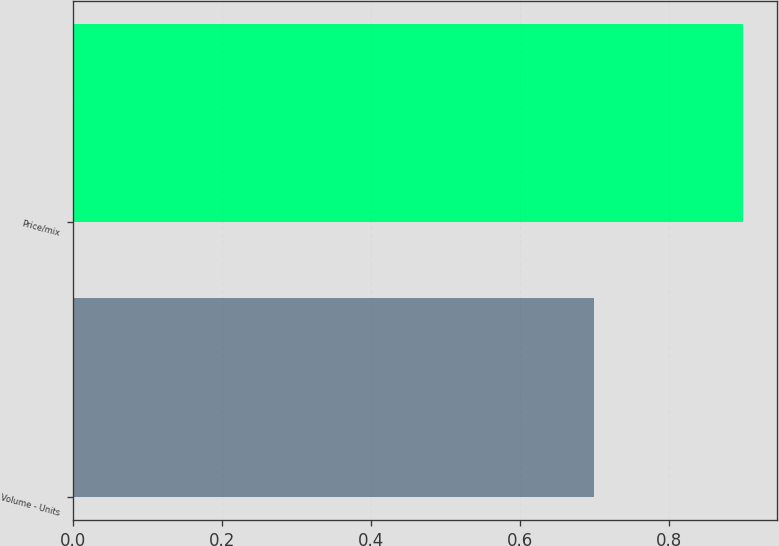Convert chart to OTSL. <chart><loc_0><loc_0><loc_500><loc_500><bar_chart><fcel>Volume - Units<fcel>Price/mix<nl><fcel>0.7<fcel>0.9<nl></chart> 